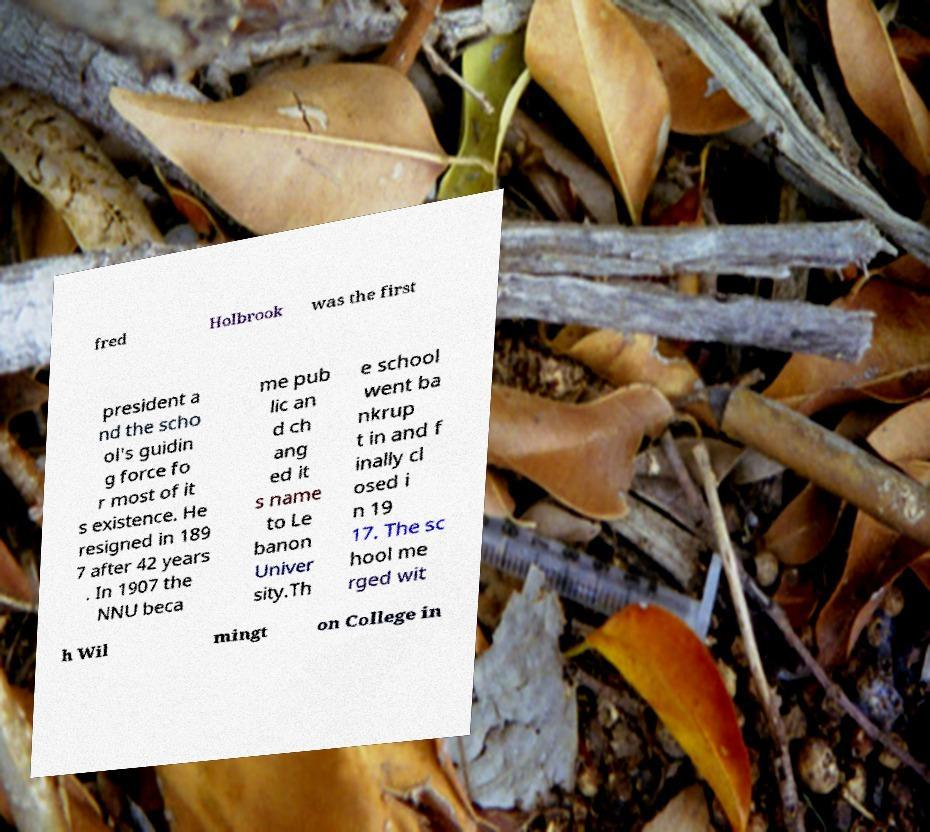There's text embedded in this image that I need extracted. Can you transcribe it verbatim? fred Holbrook was the first president a nd the scho ol's guidin g force fo r most of it s existence. He resigned in 189 7 after 42 years . In 1907 the NNU beca me pub lic an d ch ang ed it s name to Le banon Univer sity.Th e school went ba nkrup t in and f inally cl osed i n 19 17. The sc hool me rged wit h Wil mingt on College in 